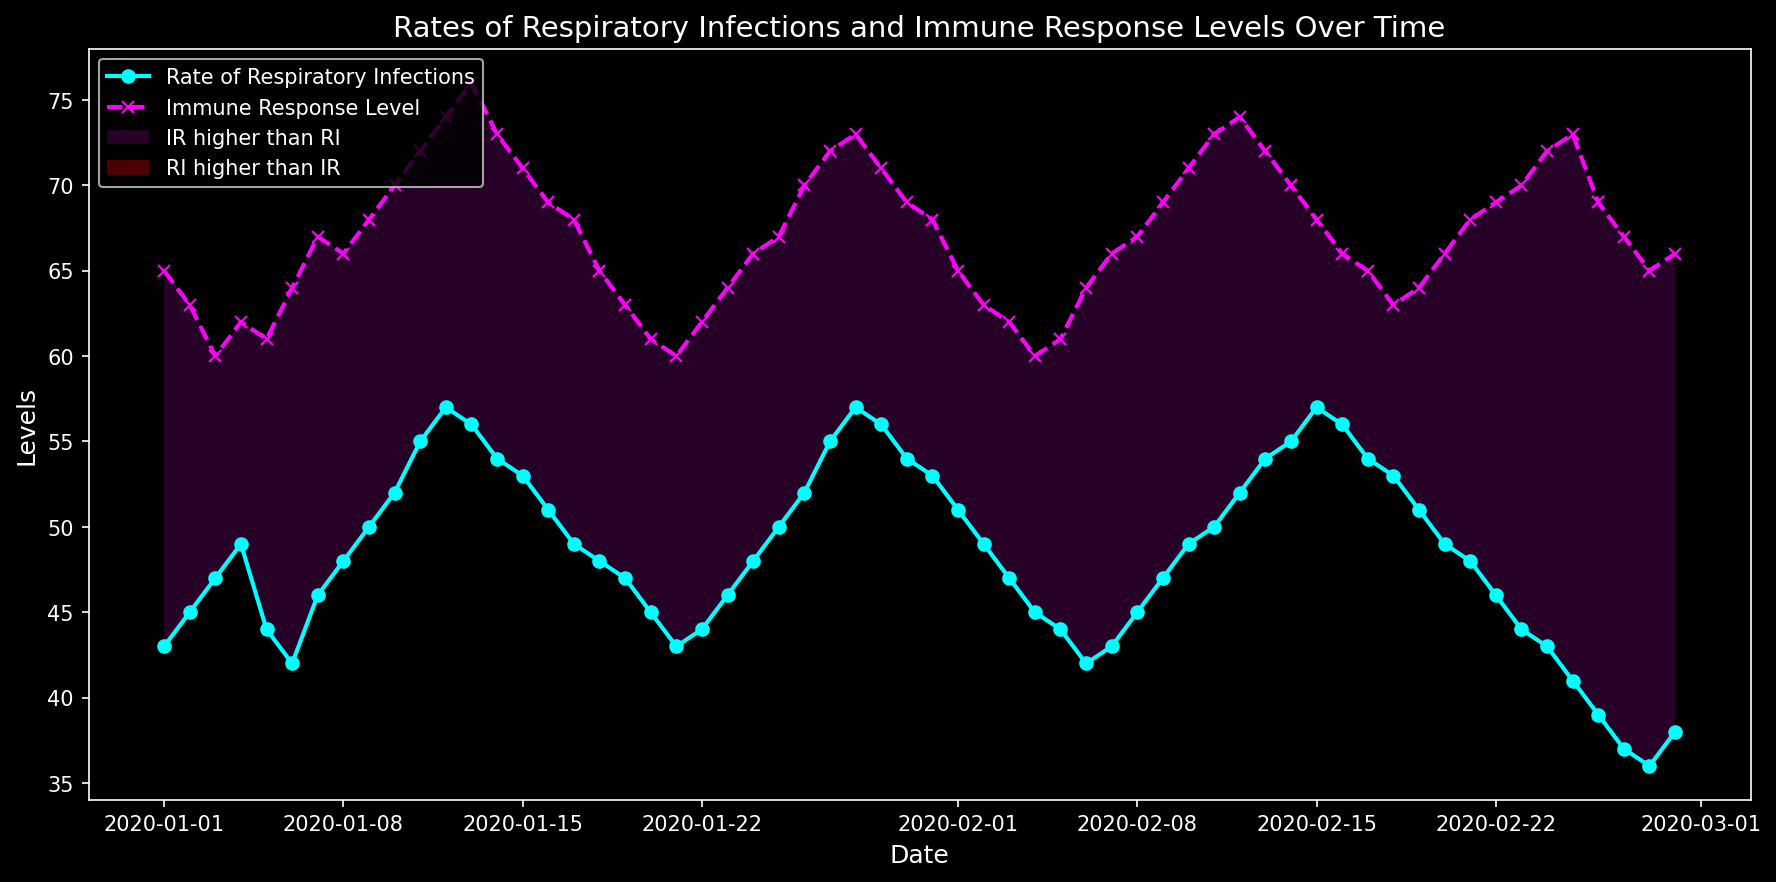What is the general trend of the respiratory infection rates over the given period? By observing the 'Rate of Respiratory Infections' line on the plot, it starts from about 43 and fluctuates, showing a slight increase and then a decline towards the end of the period, indicating varying rates but overall stability with a minor downward trend towards the end.
Answer: Fluctuating with a slight overall downward trend On which date did the immune response level hit its highest value? From the plot, the 'Immune Response Level' line reaches its peak around mid-February. Checking the exact data, February 25 shows the highest immune response level at 73.
Answer: February 25 Compare the rates of respiratory infections and immune response levels on January 31. Which one is higher? On January 31, the 'Rate of Respiratory Infections' is at 53, and the 'Immune Response Level' is at 68. Clearly, the immune response level is higher.
Answer: Immune Response Level What is the difference in values between respiratory infections and immune response levels on February 20? To find the difference, subtract the value of 'Rate of Respiratory Infections' (49) from 'Immune Response Level' (66) on February 20. 66 - 49 = 17
Answer: 17 For how many days in January were the immune response levels higher than the rates of respiratory infections? By visually assessing the plot, we can estimate the days in January when 'Immune Response Level' is above 'Rate of Respiratory Infections'. By counting these days, the immune response levels are higher than respiratory infections for the entire month, totaling 31 days.
Answer: 31 days What was the trend in the respiratory infection rate from February 23 to February 29? Observing the plot from February 23 to February 29, the 'Rate of Respiratory Infections' shows a declining trend from 44 to 38 with a brief downward spike to 36 on February 28.
Answer: Declining Which color indicates the area where the rate of respiratory infections is higher than the immune response level? In the plot, the red color fills the area where the 'Rate of Respiratory Infections' is higher than the 'Immune Response Level'.
Answer: Red What was the immune response level on February 25, and how does it relate to the respiratory infection rate on the same day? On February 25, the 'Immune Response Level' is 73, while the 'Rate of Respiratory Infections' is 41. The immune response level is significantly higher by 32 units.
Answer: 73, higher During the first week of February, are the immune response levels higher than respiratory infection rates? If so, on which days? From February 1 to February 7, the immune response levels are consistently higher than the rates of respiratory infections, as observed from the plot.
Answer: Yes, all days 